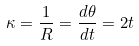<formula> <loc_0><loc_0><loc_500><loc_500>\kappa = \frac { 1 } { R } = \frac { d \theta } { d t } = 2 t</formula> 